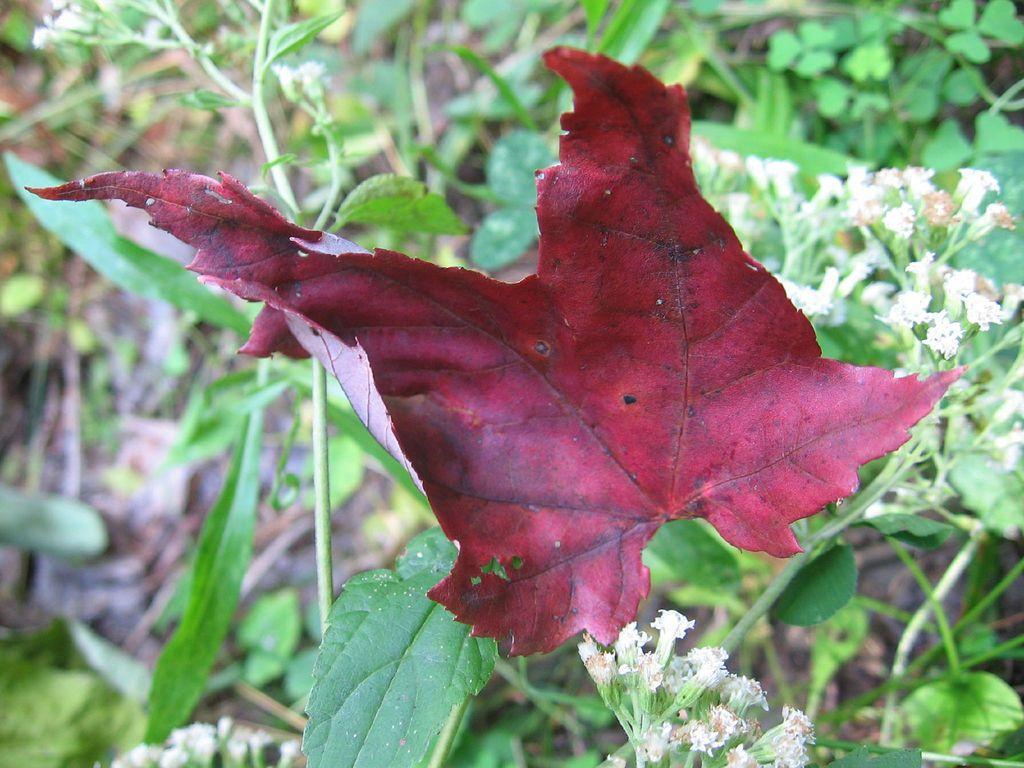Can you describe this image briefly? In this image I can see a leaf in maroon color. Background I can see few leaves in green color and flowers in white color. 